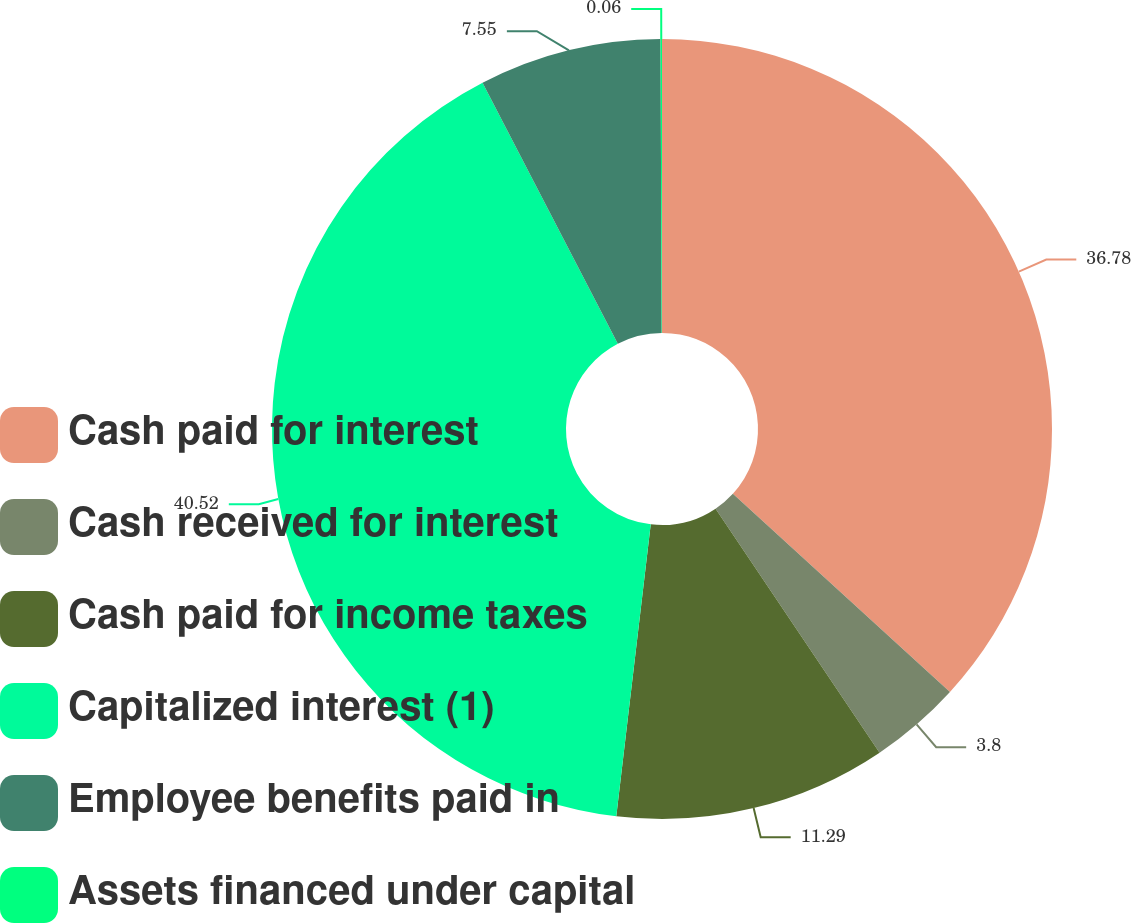Convert chart to OTSL. <chart><loc_0><loc_0><loc_500><loc_500><pie_chart><fcel>Cash paid for interest<fcel>Cash received for interest<fcel>Cash paid for income taxes<fcel>Capitalized interest (1)<fcel>Employee benefits paid in<fcel>Assets financed under capital<nl><fcel>36.78%<fcel>3.8%<fcel>11.29%<fcel>40.52%<fcel>7.55%<fcel>0.06%<nl></chart> 